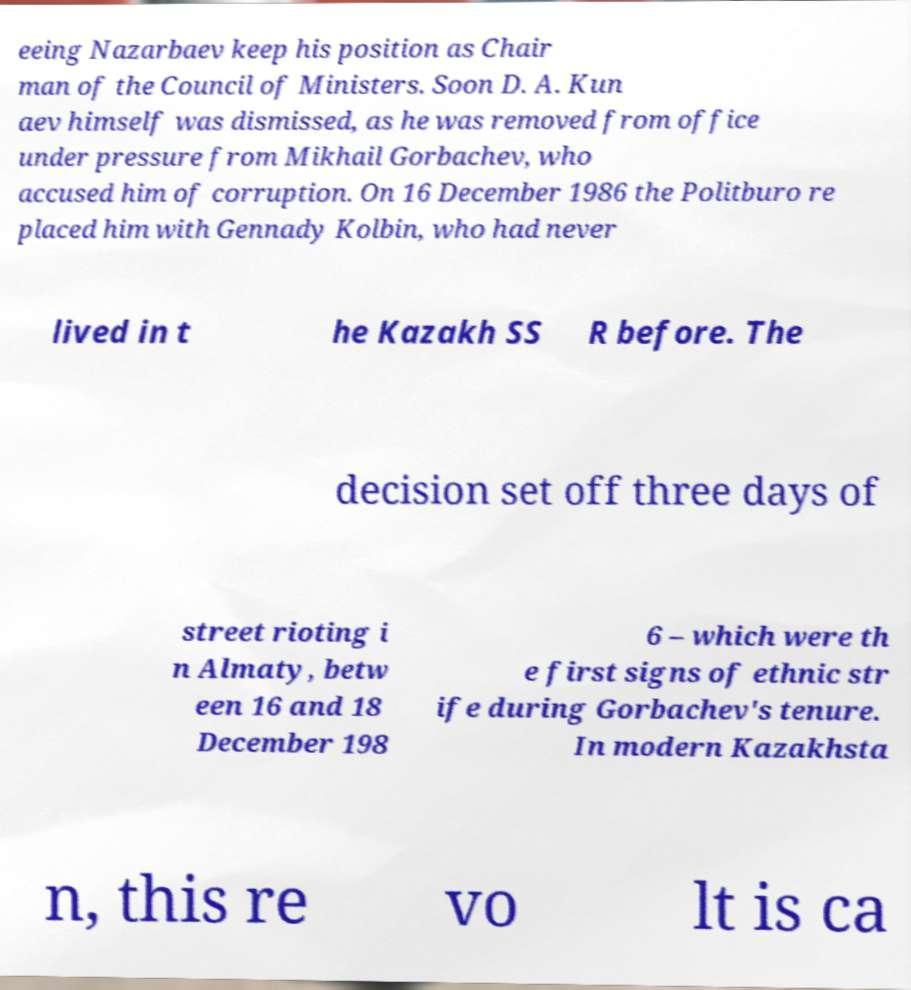Could you assist in decoding the text presented in this image and type it out clearly? eeing Nazarbaev keep his position as Chair man of the Council of Ministers. Soon D. A. Kun aev himself was dismissed, as he was removed from office under pressure from Mikhail Gorbachev, who accused him of corruption. On 16 December 1986 the Politburo re placed him with Gennady Kolbin, who had never lived in t he Kazakh SS R before. The decision set off three days of street rioting i n Almaty, betw een 16 and 18 December 198 6 – which were th e first signs of ethnic str ife during Gorbachev's tenure. In modern Kazakhsta n, this re vo lt is ca 